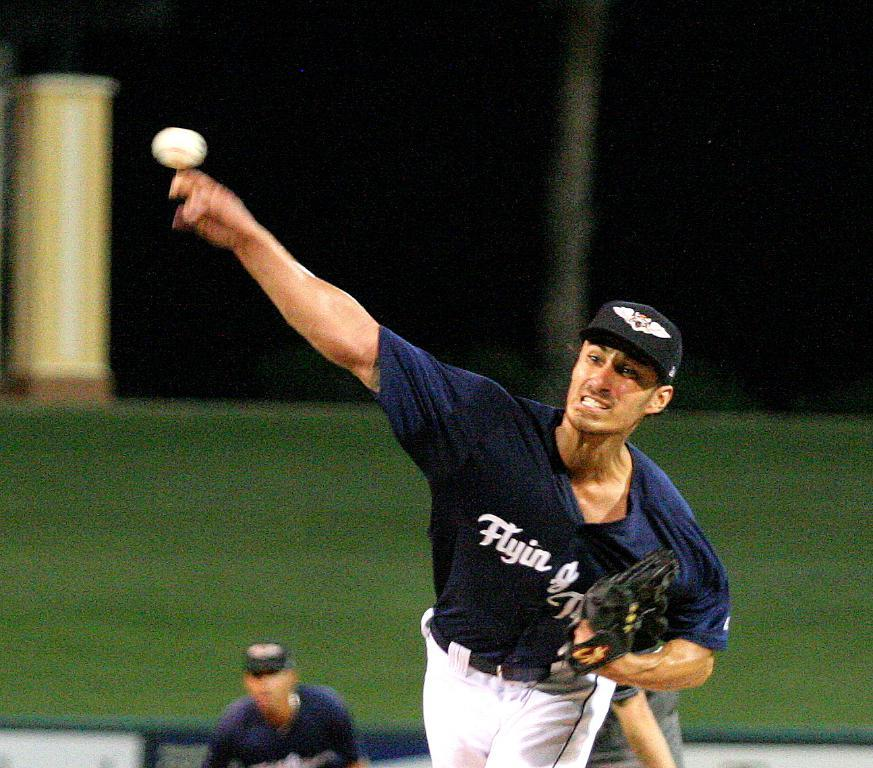<image>
Describe the image concisely. Baseball player for the Flyin team throwing a baseball. 